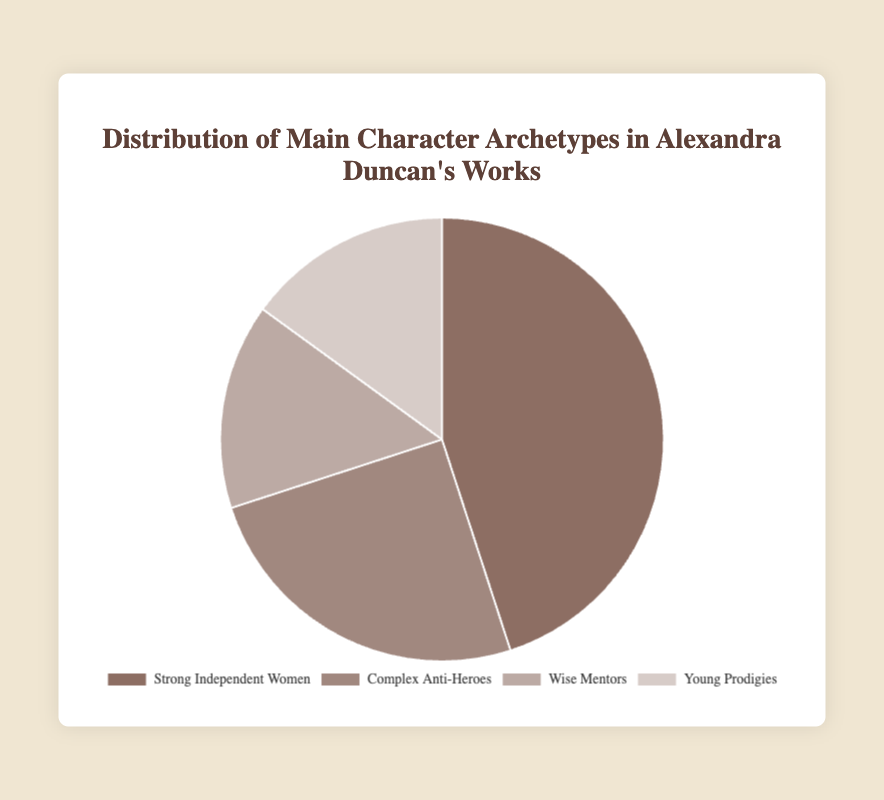Which main character archetype is most prevalent in Alexandra Duncan's works? By looking at the figure, the largest section represents Strong Independent Women which makes up 45% of the distribution.
Answer: Strong Independent Women What is the combined percentage of Complex Anti-Heroes and Wise Mentors? From the figure, Complex Anti-Heroes account for 25%, and Wise Mentors account for 15%. Adding these together yields a combined percentage of 25 + 15 = 40%.
Answer: 40% Which two archetypes have the same percentage distribution? The figure shows that Wise Mentors and Young Prodigies each make up 15% of the distribution, indicating they have identical percentages.
Answer: Wise Mentors and Young Prodigies How much larger is the percentage of Strong Independent Women compared to Complex Anti-Heroes? The figure indicates that the percentage for Strong Independent Women is 45% and for Complex Anti-Heroes is 25%. The difference can be calculated as 45 - 25 = 20%.
Answer: 20% Which archetype occupies the smallest section of the chart and what is its percentage? By observing the chart, both Wise Mentors and Young Prodigies occupy the smallest sections, each with a distribution of 15%.
Answer: Wise Mentors and Young Prodigies, 15% What is the average percentage of the four archetypes? To find the average, add all percentages: 45% (Strong Independent Women) + 25% (Complex Anti-Heroes) + 15% (Wise Mentors) + 15% (Young Prodigies) = 100%. Dividing by 4: 100 / 4 = 25%.
Answer: 25% If you combine all archetypes except Strong Independent Women, what is their total percentage? Adding up the percentages of Complex Anti-Heroes, Wise Mentors, and Young Prodigies: 25% + 15% + 15% = 55%.
Answer: 55% What color is used to represent Complex Anti-Heroes in the chart? The section for Complex Anti-Heroes in the pie chart is shown in a color similar to a soft brown.
Answer: Soft brown How do the percentages of Wise Mentors and Young Prodigies together compare to the percentage of Strong Independent Women? The sum of Wise Mentors and Young Prodigies is 15% + 15% = 30%. Strong Independent Women are 45%. Comparing these, 30% is less than 45%.
Answer: Less than 45% If you exclude the largest archetype, what percentage of the chart do the remaining three archetypes cover? Excluding Strong Independent Women at 45%, the remaining archetypes (Complex Anti-Heroes, Wise Mentors, Young Prodigies) sum to 25% + 15% + 15% = 55%.
Answer: 55% 